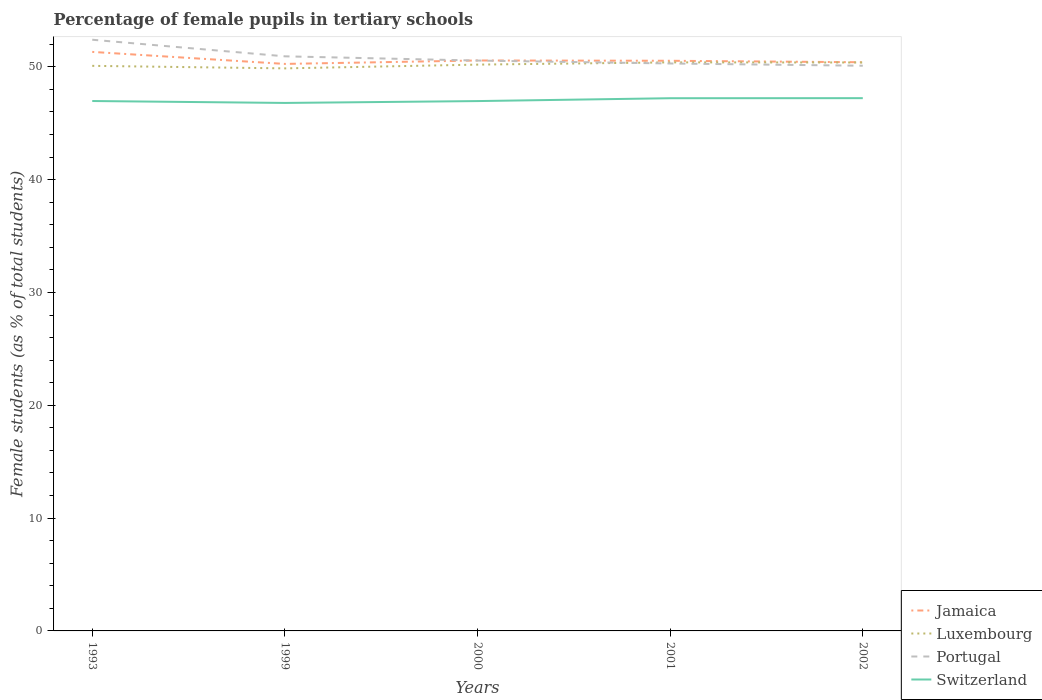Is the number of lines equal to the number of legend labels?
Give a very brief answer. Yes. Across all years, what is the maximum percentage of female pupils in tertiary schools in Jamaica?
Provide a succinct answer. 50.26. In which year was the percentage of female pupils in tertiary schools in Switzerland maximum?
Ensure brevity in your answer.  1999. What is the total percentage of female pupils in tertiary schools in Portugal in the graph?
Give a very brief answer. 1.85. What is the difference between the highest and the second highest percentage of female pupils in tertiary schools in Portugal?
Your answer should be compact. 2.3. How many lines are there?
Your response must be concise. 4. What is the difference between two consecutive major ticks on the Y-axis?
Keep it short and to the point. 10. Does the graph contain any zero values?
Ensure brevity in your answer.  No. How many legend labels are there?
Offer a terse response. 4. How are the legend labels stacked?
Your answer should be very brief. Vertical. What is the title of the graph?
Your response must be concise. Percentage of female pupils in tertiary schools. Does "Marshall Islands" appear as one of the legend labels in the graph?
Ensure brevity in your answer.  No. What is the label or title of the X-axis?
Provide a succinct answer. Years. What is the label or title of the Y-axis?
Your answer should be compact. Female students (as % of total students). What is the Female students (as % of total students) in Jamaica in 1993?
Provide a short and direct response. 51.32. What is the Female students (as % of total students) in Luxembourg in 1993?
Provide a short and direct response. 50.08. What is the Female students (as % of total students) in Portugal in 1993?
Your response must be concise. 52.4. What is the Female students (as % of total students) of Switzerland in 1993?
Keep it short and to the point. 46.97. What is the Female students (as % of total students) of Jamaica in 1999?
Offer a terse response. 50.26. What is the Female students (as % of total students) in Luxembourg in 1999?
Offer a terse response. 49.86. What is the Female students (as % of total students) in Portugal in 1999?
Make the answer very short. 50.93. What is the Female students (as % of total students) of Switzerland in 1999?
Ensure brevity in your answer.  46.8. What is the Female students (as % of total students) in Jamaica in 2000?
Provide a short and direct response. 50.56. What is the Female students (as % of total students) of Luxembourg in 2000?
Your answer should be compact. 50.19. What is the Female students (as % of total students) of Portugal in 2000?
Provide a succinct answer. 50.55. What is the Female students (as % of total students) of Switzerland in 2000?
Your answer should be compact. 46.96. What is the Female students (as % of total students) of Jamaica in 2001?
Give a very brief answer. 50.53. What is the Female students (as % of total students) in Luxembourg in 2001?
Provide a succinct answer. 50.39. What is the Female students (as % of total students) in Portugal in 2001?
Keep it short and to the point. 50.29. What is the Female students (as % of total students) in Switzerland in 2001?
Ensure brevity in your answer.  47.21. What is the Female students (as % of total students) of Jamaica in 2002?
Your response must be concise. 50.4. What is the Female students (as % of total students) in Luxembourg in 2002?
Give a very brief answer. 50.38. What is the Female students (as % of total students) of Portugal in 2002?
Make the answer very short. 50.09. What is the Female students (as % of total students) of Switzerland in 2002?
Provide a succinct answer. 47.22. Across all years, what is the maximum Female students (as % of total students) in Jamaica?
Provide a short and direct response. 51.32. Across all years, what is the maximum Female students (as % of total students) in Luxembourg?
Your response must be concise. 50.39. Across all years, what is the maximum Female students (as % of total students) in Portugal?
Your response must be concise. 52.4. Across all years, what is the maximum Female students (as % of total students) of Switzerland?
Your answer should be compact. 47.22. Across all years, what is the minimum Female students (as % of total students) of Jamaica?
Keep it short and to the point. 50.26. Across all years, what is the minimum Female students (as % of total students) of Luxembourg?
Provide a succinct answer. 49.86. Across all years, what is the minimum Female students (as % of total students) in Portugal?
Give a very brief answer. 50.09. Across all years, what is the minimum Female students (as % of total students) in Switzerland?
Your answer should be very brief. 46.8. What is the total Female students (as % of total students) of Jamaica in the graph?
Keep it short and to the point. 253.07. What is the total Female students (as % of total students) in Luxembourg in the graph?
Offer a very short reply. 250.91. What is the total Female students (as % of total students) in Portugal in the graph?
Offer a very short reply. 254.27. What is the total Female students (as % of total students) in Switzerland in the graph?
Make the answer very short. 235.16. What is the difference between the Female students (as % of total students) in Jamaica in 1993 and that in 1999?
Offer a very short reply. 1.07. What is the difference between the Female students (as % of total students) in Luxembourg in 1993 and that in 1999?
Offer a terse response. 0.22. What is the difference between the Female students (as % of total students) in Portugal in 1993 and that in 1999?
Provide a succinct answer. 1.47. What is the difference between the Female students (as % of total students) in Switzerland in 1993 and that in 1999?
Your answer should be very brief. 0.17. What is the difference between the Female students (as % of total students) of Jamaica in 1993 and that in 2000?
Provide a succinct answer. 0.76. What is the difference between the Female students (as % of total students) in Luxembourg in 1993 and that in 2000?
Give a very brief answer. -0.11. What is the difference between the Female students (as % of total students) of Portugal in 1993 and that in 2000?
Provide a short and direct response. 1.85. What is the difference between the Female students (as % of total students) in Switzerland in 1993 and that in 2000?
Your answer should be compact. 0.01. What is the difference between the Female students (as % of total students) of Jamaica in 1993 and that in 2001?
Offer a very short reply. 0.79. What is the difference between the Female students (as % of total students) in Luxembourg in 1993 and that in 2001?
Provide a short and direct response. -0.31. What is the difference between the Female students (as % of total students) in Portugal in 1993 and that in 2001?
Ensure brevity in your answer.  2.1. What is the difference between the Female students (as % of total students) in Switzerland in 1993 and that in 2001?
Ensure brevity in your answer.  -0.25. What is the difference between the Female students (as % of total students) in Jamaica in 1993 and that in 2002?
Give a very brief answer. 0.92. What is the difference between the Female students (as % of total students) in Luxembourg in 1993 and that in 2002?
Keep it short and to the point. -0.3. What is the difference between the Female students (as % of total students) of Portugal in 1993 and that in 2002?
Make the answer very short. 2.3. What is the difference between the Female students (as % of total students) of Switzerland in 1993 and that in 2002?
Provide a short and direct response. -0.25. What is the difference between the Female students (as % of total students) in Jamaica in 1999 and that in 2000?
Make the answer very short. -0.3. What is the difference between the Female students (as % of total students) in Luxembourg in 1999 and that in 2000?
Keep it short and to the point. -0.33. What is the difference between the Female students (as % of total students) in Portugal in 1999 and that in 2000?
Offer a very short reply. 0.38. What is the difference between the Female students (as % of total students) in Switzerland in 1999 and that in 2000?
Your response must be concise. -0.16. What is the difference between the Female students (as % of total students) in Jamaica in 1999 and that in 2001?
Keep it short and to the point. -0.28. What is the difference between the Female students (as % of total students) of Luxembourg in 1999 and that in 2001?
Offer a very short reply. -0.53. What is the difference between the Female students (as % of total students) in Portugal in 1999 and that in 2001?
Your response must be concise. 0.63. What is the difference between the Female students (as % of total students) in Switzerland in 1999 and that in 2001?
Your answer should be very brief. -0.42. What is the difference between the Female students (as % of total students) in Jamaica in 1999 and that in 2002?
Give a very brief answer. -0.15. What is the difference between the Female students (as % of total students) in Luxembourg in 1999 and that in 2002?
Your answer should be compact. -0.52. What is the difference between the Female students (as % of total students) of Portugal in 1999 and that in 2002?
Keep it short and to the point. 0.83. What is the difference between the Female students (as % of total students) in Switzerland in 1999 and that in 2002?
Provide a short and direct response. -0.42. What is the difference between the Female students (as % of total students) in Jamaica in 2000 and that in 2001?
Your response must be concise. 0.03. What is the difference between the Female students (as % of total students) in Luxembourg in 2000 and that in 2001?
Your answer should be compact. -0.2. What is the difference between the Female students (as % of total students) of Portugal in 2000 and that in 2001?
Keep it short and to the point. 0.26. What is the difference between the Female students (as % of total students) in Switzerland in 2000 and that in 2001?
Your response must be concise. -0.25. What is the difference between the Female students (as % of total students) in Jamaica in 2000 and that in 2002?
Offer a very short reply. 0.16. What is the difference between the Female students (as % of total students) in Luxembourg in 2000 and that in 2002?
Offer a very short reply. -0.19. What is the difference between the Female students (as % of total students) in Portugal in 2000 and that in 2002?
Your response must be concise. 0.46. What is the difference between the Female students (as % of total students) of Switzerland in 2000 and that in 2002?
Offer a very short reply. -0.26. What is the difference between the Female students (as % of total students) of Jamaica in 2001 and that in 2002?
Ensure brevity in your answer.  0.13. What is the difference between the Female students (as % of total students) in Luxembourg in 2001 and that in 2002?
Provide a succinct answer. 0.01. What is the difference between the Female students (as % of total students) in Portugal in 2001 and that in 2002?
Ensure brevity in your answer.  0.2. What is the difference between the Female students (as % of total students) of Switzerland in 2001 and that in 2002?
Provide a succinct answer. -0.01. What is the difference between the Female students (as % of total students) of Jamaica in 1993 and the Female students (as % of total students) of Luxembourg in 1999?
Your answer should be very brief. 1.46. What is the difference between the Female students (as % of total students) of Jamaica in 1993 and the Female students (as % of total students) of Portugal in 1999?
Your answer should be very brief. 0.39. What is the difference between the Female students (as % of total students) of Jamaica in 1993 and the Female students (as % of total students) of Switzerland in 1999?
Provide a short and direct response. 4.52. What is the difference between the Female students (as % of total students) in Luxembourg in 1993 and the Female students (as % of total students) in Portugal in 1999?
Offer a very short reply. -0.84. What is the difference between the Female students (as % of total students) in Luxembourg in 1993 and the Female students (as % of total students) in Switzerland in 1999?
Your response must be concise. 3.29. What is the difference between the Female students (as % of total students) in Portugal in 1993 and the Female students (as % of total students) in Switzerland in 1999?
Your answer should be compact. 5.6. What is the difference between the Female students (as % of total students) in Jamaica in 1993 and the Female students (as % of total students) in Luxembourg in 2000?
Your answer should be compact. 1.13. What is the difference between the Female students (as % of total students) of Jamaica in 1993 and the Female students (as % of total students) of Portugal in 2000?
Make the answer very short. 0.77. What is the difference between the Female students (as % of total students) of Jamaica in 1993 and the Female students (as % of total students) of Switzerland in 2000?
Your answer should be compact. 4.36. What is the difference between the Female students (as % of total students) in Luxembourg in 1993 and the Female students (as % of total students) in Portugal in 2000?
Make the answer very short. -0.47. What is the difference between the Female students (as % of total students) in Luxembourg in 1993 and the Female students (as % of total students) in Switzerland in 2000?
Provide a succinct answer. 3.12. What is the difference between the Female students (as % of total students) in Portugal in 1993 and the Female students (as % of total students) in Switzerland in 2000?
Make the answer very short. 5.44. What is the difference between the Female students (as % of total students) in Jamaica in 1993 and the Female students (as % of total students) in Luxembourg in 2001?
Keep it short and to the point. 0.93. What is the difference between the Female students (as % of total students) in Jamaica in 1993 and the Female students (as % of total students) in Portugal in 2001?
Provide a short and direct response. 1.03. What is the difference between the Female students (as % of total students) of Jamaica in 1993 and the Female students (as % of total students) of Switzerland in 2001?
Ensure brevity in your answer.  4.11. What is the difference between the Female students (as % of total students) of Luxembourg in 1993 and the Female students (as % of total students) of Portugal in 2001?
Provide a succinct answer. -0.21. What is the difference between the Female students (as % of total students) of Luxembourg in 1993 and the Female students (as % of total students) of Switzerland in 2001?
Keep it short and to the point. 2.87. What is the difference between the Female students (as % of total students) in Portugal in 1993 and the Female students (as % of total students) in Switzerland in 2001?
Offer a very short reply. 5.18. What is the difference between the Female students (as % of total students) of Jamaica in 1993 and the Female students (as % of total students) of Luxembourg in 2002?
Ensure brevity in your answer.  0.94. What is the difference between the Female students (as % of total students) of Jamaica in 1993 and the Female students (as % of total students) of Portugal in 2002?
Ensure brevity in your answer.  1.23. What is the difference between the Female students (as % of total students) in Jamaica in 1993 and the Female students (as % of total students) in Switzerland in 2002?
Ensure brevity in your answer.  4.1. What is the difference between the Female students (as % of total students) in Luxembourg in 1993 and the Female students (as % of total students) in Portugal in 2002?
Offer a terse response. -0.01. What is the difference between the Female students (as % of total students) of Luxembourg in 1993 and the Female students (as % of total students) of Switzerland in 2002?
Your answer should be very brief. 2.86. What is the difference between the Female students (as % of total students) of Portugal in 1993 and the Female students (as % of total students) of Switzerland in 2002?
Ensure brevity in your answer.  5.18. What is the difference between the Female students (as % of total students) in Jamaica in 1999 and the Female students (as % of total students) in Luxembourg in 2000?
Keep it short and to the point. 0.06. What is the difference between the Female students (as % of total students) of Jamaica in 1999 and the Female students (as % of total students) of Portugal in 2000?
Make the answer very short. -0.3. What is the difference between the Female students (as % of total students) of Jamaica in 1999 and the Female students (as % of total students) of Switzerland in 2000?
Give a very brief answer. 3.29. What is the difference between the Female students (as % of total students) in Luxembourg in 1999 and the Female students (as % of total students) in Portugal in 2000?
Make the answer very short. -0.69. What is the difference between the Female students (as % of total students) of Luxembourg in 1999 and the Female students (as % of total students) of Switzerland in 2000?
Offer a terse response. 2.9. What is the difference between the Female students (as % of total students) of Portugal in 1999 and the Female students (as % of total students) of Switzerland in 2000?
Offer a terse response. 3.97. What is the difference between the Female students (as % of total students) in Jamaica in 1999 and the Female students (as % of total students) in Luxembourg in 2001?
Keep it short and to the point. -0.14. What is the difference between the Female students (as % of total students) in Jamaica in 1999 and the Female students (as % of total students) in Portugal in 2001?
Ensure brevity in your answer.  -0.04. What is the difference between the Female students (as % of total students) of Jamaica in 1999 and the Female students (as % of total students) of Switzerland in 2001?
Your answer should be very brief. 3.04. What is the difference between the Female students (as % of total students) of Luxembourg in 1999 and the Female students (as % of total students) of Portugal in 2001?
Give a very brief answer. -0.43. What is the difference between the Female students (as % of total students) in Luxembourg in 1999 and the Female students (as % of total students) in Switzerland in 2001?
Keep it short and to the point. 2.65. What is the difference between the Female students (as % of total students) in Portugal in 1999 and the Female students (as % of total students) in Switzerland in 2001?
Provide a short and direct response. 3.71. What is the difference between the Female students (as % of total students) of Jamaica in 1999 and the Female students (as % of total students) of Luxembourg in 2002?
Your response must be concise. -0.13. What is the difference between the Female students (as % of total students) of Jamaica in 1999 and the Female students (as % of total students) of Portugal in 2002?
Give a very brief answer. 0.16. What is the difference between the Female students (as % of total students) of Jamaica in 1999 and the Female students (as % of total students) of Switzerland in 2002?
Offer a terse response. 3.03. What is the difference between the Female students (as % of total students) in Luxembourg in 1999 and the Female students (as % of total students) in Portugal in 2002?
Offer a very short reply. -0.23. What is the difference between the Female students (as % of total students) in Luxembourg in 1999 and the Female students (as % of total students) in Switzerland in 2002?
Your response must be concise. 2.64. What is the difference between the Female students (as % of total students) of Portugal in 1999 and the Female students (as % of total students) of Switzerland in 2002?
Your answer should be very brief. 3.71. What is the difference between the Female students (as % of total students) of Jamaica in 2000 and the Female students (as % of total students) of Luxembourg in 2001?
Provide a succinct answer. 0.17. What is the difference between the Female students (as % of total students) of Jamaica in 2000 and the Female students (as % of total students) of Portugal in 2001?
Keep it short and to the point. 0.27. What is the difference between the Female students (as % of total students) in Jamaica in 2000 and the Female students (as % of total students) in Switzerland in 2001?
Offer a very short reply. 3.35. What is the difference between the Female students (as % of total students) of Luxembourg in 2000 and the Female students (as % of total students) of Switzerland in 2001?
Give a very brief answer. 2.98. What is the difference between the Female students (as % of total students) in Portugal in 2000 and the Female students (as % of total students) in Switzerland in 2001?
Offer a terse response. 3.34. What is the difference between the Female students (as % of total students) of Jamaica in 2000 and the Female students (as % of total students) of Luxembourg in 2002?
Keep it short and to the point. 0.18. What is the difference between the Female students (as % of total students) in Jamaica in 2000 and the Female students (as % of total students) in Portugal in 2002?
Your response must be concise. 0.47. What is the difference between the Female students (as % of total students) in Jamaica in 2000 and the Female students (as % of total students) in Switzerland in 2002?
Offer a terse response. 3.34. What is the difference between the Female students (as % of total students) of Luxembourg in 2000 and the Female students (as % of total students) of Portugal in 2002?
Your response must be concise. 0.1. What is the difference between the Female students (as % of total students) of Luxembourg in 2000 and the Female students (as % of total students) of Switzerland in 2002?
Ensure brevity in your answer.  2.97. What is the difference between the Female students (as % of total students) in Portugal in 2000 and the Female students (as % of total students) in Switzerland in 2002?
Your answer should be compact. 3.33. What is the difference between the Female students (as % of total students) in Jamaica in 2001 and the Female students (as % of total students) in Luxembourg in 2002?
Your answer should be very brief. 0.15. What is the difference between the Female students (as % of total students) of Jamaica in 2001 and the Female students (as % of total students) of Portugal in 2002?
Offer a very short reply. 0.44. What is the difference between the Female students (as % of total students) in Jamaica in 2001 and the Female students (as % of total students) in Switzerland in 2002?
Provide a short and direct response. 3.31. What is the difference between the Female students (as % of total students) of Luxembourg in 2001 and the Female students (as % of total students) of Portugal in 2002?
Make the answer very short. 0.3. What is the difference between the Female students (as % of total students) in Luxembourg in 2001 and the Female students (as % of total students) in Switzerland in 2002?
Provide a short and direct response. 3.17. What is the difference between the Female students (as % of total students) in Portugal in 2001 and the Female students (as % of total students) in Switzerland in 2002?
Keep it short and to the point. 3.07. What is the average Female students (as % of total students) of Jamaica per year?
Your answer should be compact. 50.61. What is the average Female students (as % of total students) in Luxembourg per year?
Offer a terse response. 50.18. What is the average Female students (as % of total students) of Portugal per year?
Your answer should be very brief. 50.85. What is the average Female students (as % of total students) in Switzerland per year?
Make the answer very short. 47.03. In the year 1993, what is the difference between the Female students (as % of total students) of Jamaica and Female students (as % of total students) of Luxembourg?
Make the answer very short. 1.24. In the year 1993, what is the difference between the Female students (as % of total students) of Jamaica and Female students (as % of total students) of Portugal?
Keep it short and to the point. -1.08. In the year 1993, what is the difference between the Female students (as % of total students) of Jamaica and Female students (as % of total students) of Switzerland?
Your answer should be very brief. 4.35. In the year 1993, what is the difference between the Female students (as % of total students) in Luxembourg and Female students (as % of total students) in Portugal?
Give a very brief answer. -2.31. In the year 1993, what is the difference between the Female students (as % of total students) of Luxembourg and Female students (as % of total students) of Switzerland?
Provide a succinct answer. 3.12. In the year 1993, what is the difference between the Female students (as % of total students) of Portugal and Female students (as % of total students) of Switzerland?
Your answer should be very brief. 5.43. In the year 1999, what is the difference between the Female students (as % of total students) of Jamaica and Female students (as % of total students) of Luxembourg?
Provide a short and direct response. 0.4. In the year 1999, what is the difference between the Female students (as % of total students) in Jamaica and Female students (as % of total students) in Portugal?
Keep it short and to the point. -0.67. In the year 1999, what is the difference between the Female students (as % of total students) in Jamaica and Female students (as % of total students) in Switzerland?
Ensure brevity in your answer.  3.46. In the year 1999, what is the difference between the Female students (as % of total students) in Luxembourg and Female students (as % of total students) in Portugal?
Provide a short and direct response. -1.07. In the year 1999, what is the difference between the Female students (as % of total students) in Luxembourg and Female students (as % of total students) in Switzerland?
Your answer should be compact. 3.06. In the year 1999, what is the difference between the Female students (as % of total students) in Portugal and Female students (as % of total students) in Switzerland?
Provide a succinct answer. 4.13. In the year 2000, what is the difference between the Female students (as % of total students) in Jamaica and Female students (as % of total students) in Luxembourg?
Your answer should be very brief. 0.37. In the year 2000, what is the difference between the Female students (as % of total students) of Jamaica and Female students (as % of total students) of Portugal?
Ensure brevity in your answer.  0.01. In the year 2000, what is the difference between the Female students (as % of total students) in Jamaica and Female students (as % of total students) in Switzerland?
Ensure brevity in your answer.  3.6. In the year 2000, what is the difference between the Female students (as % of total students) of Luxembourg and Female students (as % of total students) of Portugal?
Your response must be concise. -0.36. In the year 2000, what is the difference between the Female students (as % of total students) of Luxembourg and Female students (as % of total students) of Switzerland?
Provide a short and direct response. 3.23. In the year 2000, what is the difference between the Female students (as % of total students) in Portugal and Female students (as % of total students) in Switzerland?
Your answer should be compact. 3.59. In the year 2001, what is the difference between the Female students (as % of total students) in Jamaica and Female students (as % of total students) in Luxembourg?
Give a very brief answer. 0.14. In the year 2001, what is the difference between the Female students (as % of total students) of Jamaica and Female students (as % of total students) of Portugal?
Make the answer very short. 0.24. In the year 2001, what is the difference between the Female students (as % of total students) of Jamaica and Female students (as % of total students) of Switzerland?
Your answer should be compact. 3.32. In the year 2001, what is the difference between the Female students (as % of total students) of Luxembourg and Female students (as % of total students) of Portugal?
Give a very brief answer. 0.1. In the year 2001, what is the difference between the Female students (as % of total students) in Luxembourg and Female students (as % of total students) in Switzerland?
Provide a succinct answer. 3.18. In the year 2001, what is the difference between the Female students (as % of total students) in Portugal and Female students (as % of total students) in Switzerland?
Provide a short and direct response. 3.08. In the year 2002, what is the difference between the Female students (as % of total students) in Jamaica and Female students (as % of total students) in Luxembourg?
Keep it short and to the point. 0.02. In the year 2002, what is the difference between the Female students (as % of total students) of Jamaica and Female students (as % of total students) of Portugal?
Provide a succinct answer. 0.31. In the year 2002, what is the difference between the Female students (as % of total students) of Jamaica and Female students (as % of total students) of Switzerland?
Give a very brief answer. 3.18. In the year 2002, what is the difference between the Female students (as % of total students) in Luxembourg and Female students (as % of total students) in Portugal?
Provide a short and direct response. 0.29. In the year 2002, what is the difference between the Female students (as % of total students) of Luxembourg and Female students (as % of total students) of Switzerland?
Provide a short and direct response. 3.16. In the year 2002, what is the difference between the Female students (as % of total students) in Portugal and Female students (as % of total students) in Switzerland?
Make the answer very short. 2.87. What is the ratio of the Female students (as % of total students) in Jamaica in 1993 to that in 1999?
Your response must be concise. 1.02. What is the ratio of the Female students (as % of total students) of Luxembourg in 1993 to that in 1999?
Ensure brevity in your answer.  1. What is the ratio of the Female students (as % of total students) in Portugal in 1993 to that in 1999?
Offer a terse response. 1.03. What is the ratio of the Female students (as % of total students) of Jamaica in 1993 to that in 2000?
Your answer should be compact. 1.01. What is the ratio of the Female students (as % of total students) of Luxembourg in 1993 to that in 2000?
Keep it short and to the point. 1. What is the ratio of the Female students (as % of total students) of Portugal in 1993 to that in 2000?
Ensure brevity in your answer.  1.04. What is the ratio of the Female students (as % of total students) in Jamaica in 1993 to that in 2001?
Provide a short and direct response. 1.02. What is the ratio of the Female students (as % of total students) in Portugal in 1993 to that in 2001?
Provide a succinct answer. 1.04. What is the ratio of the Female students (as % of total students) in Switzerland in 1993 to that in 2001?
Ensure brevity in your answer.  0.99. What is the ratio of the Female students (as % of total students) in Jamaica in 1993 to that in 2002?
Your response must be concise. 1.02. What is the ratio of the Female students (as % of total students) of Portugal in 1993 to that in 2002?
Keep it short and to the point. 1.05. What is the ratio of the Female students (as % of total students) in Jamaica in 1999 to that in 2000?
Make the answer very short. 0.99. What is the ratio of the Female students (as % of total students) of Portugal in 1999 to that in 2000?
Provide a short and direct response. 1.01. What is the ratio of the Female students (as % of total students) in Jamaica in 1999 to that in 2001?
Make the answer very short. 0.99. What is the ratio of the Female students (as % of total students) of Luxembourg in 1999 to that in 2001?
Ensure brevity in your answer.  0.99. What is the ratio of the Female students (as % of total students) of Portugal in 1999 to that in 2001?
Your answer should be compact. 1.01. What is the ratio of the Female students (as % of total students) of Switzerland in 1999 to that in 2001?
Ensure brevity in your answer.  0.99. What is the ratio of the Female students (as % of total students) of Portugal in 1999 to that in 2002?
Keep it short and to the point. 1.02. What is the ratio of the Female students (as % of total students) in Jamaica in 2000 to that in 2001?
Provide a short and direct response. 1. What is the ratio of the Female students (as % of total students) of Luxembourg in 2000 to that in 2001?
Offer a terse response. 1. What is the ratio of the Female students (as % of total students) in Portugal in 2000 to that in 2001?
Keep it short and to the point. 1.01. What is the ratio of the Female students (as % of total students) in Jamaica in 2000 to that in 2002?
Provide a short and direct response. 1. What is the ratio of the Female students (as % of total students) of Luxembourg in 2000 to that in 2002?
Your answer should be very brief. 1. What is the ratio of the Female students (as % of total students) of Portugal in 2000 to that in 2002?
Your response must be concise. 1.01. What is the ratio of the Female students (as % of total students) in Switzerland in 2000 to that in 2002?
Your answer should be very brief. 0.99. What is the ratio of the Female students (as % of total students) in Jamaica in 2001 to that in 2002?
Give a very brief answer. 1. What is the ratio of the Female students (as % of total students) of Luxembourg in 2001 to that in 2002?
Ensure brevity in your answer.  1. What is the ratio of the Female students (as % of total students) of Portugal in 2001 to that in 2002?
Keep it short and to the point. 1. What is the ratio of the Female students (as % of total students) in Switzerland in 2001 to that in 2002?
Ensure brevity in your answer.  1. What is the difference between the highest and the second highest Female students (as % of total students) in Jamaica?
Provide a succinct answer. 0.76. What is the difference between the highest and the second highest Female students (as % of total students) in Luxembourg?
Make the answer very short. 0.01. What is the difference between the highest and the second highest Female students (as % of total students) of Portugal?
Your answer should be compact. 1.47. What is the difference between the highest and the second highest Female students (as % of total students) in Switzerland?
Your response must be concise. 0.01. What is the difference between the highest and the lowest Female students (as % of total students) in Jamaica?
Offer a terse response. 1.07. What is the difference between the highest and the lowest Female students (as % of total students) of Luxembourg?
Offer a terse response. 0.53. What is the difference between the highest and the lowest Female students (as % of total students) in Portugal?
Make the answer very short. 2.3. What is the difference between the highest and the lowest Female students (as % of total students) in Switzerland?
Your answer should be compact. 0.42. 